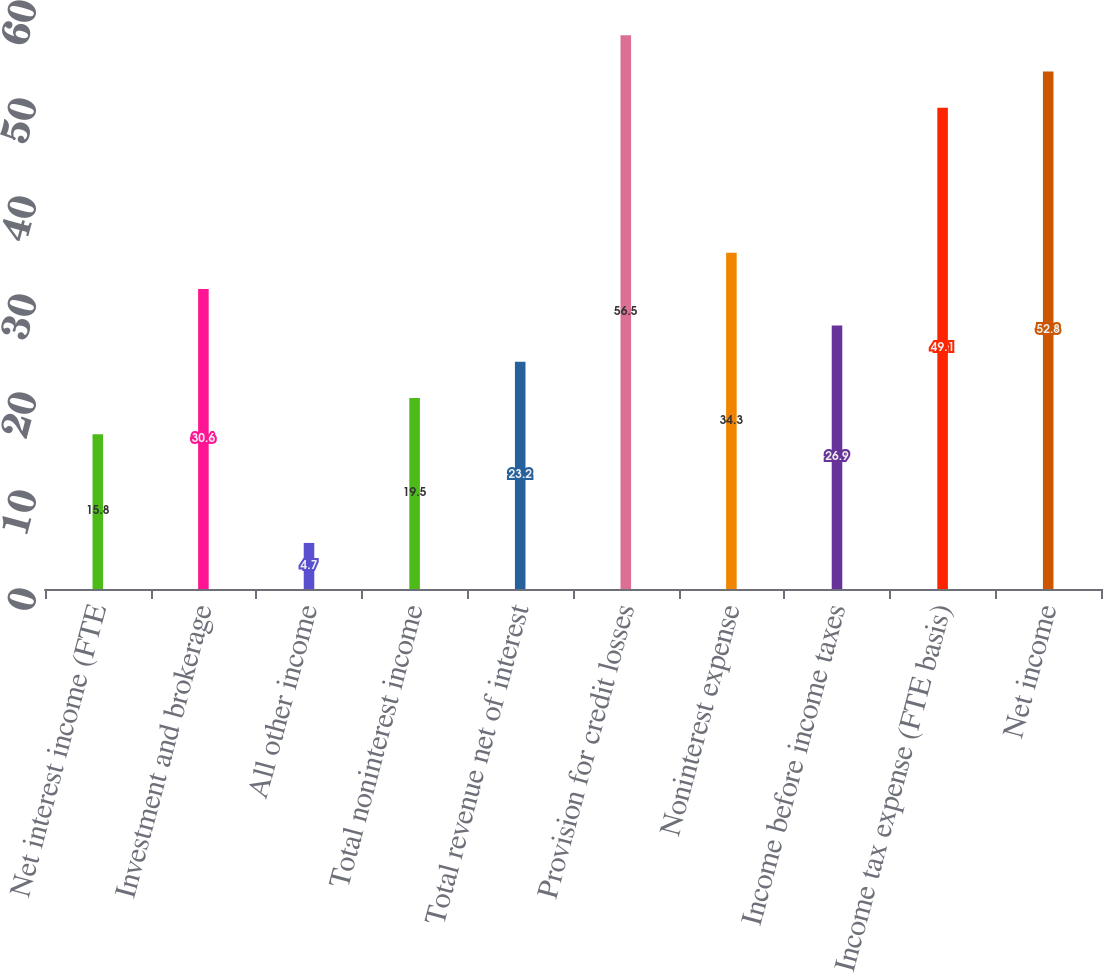Convert chart. <chart><loc_0><loc_0><loc_500><loc_500><bar_chart><fcel>Net interest income (FTE<fcel>Investment and brokerage<fcel>All other income<fcel>Total noninterest income<fcel>Total revenue net of interest<fcel>Provision for credit losses<fcel>Noninterest expense<fcel>Income before income taxes<fcel>Income tax expense (FTE basis)<fcel>Net income<nl><fcel>15.8<fcel>30.6<fcel>4.7<fcel>19.5<fcel>23.2<fcel>56.5<fcel>34.3<fcel>26.9<fcel>49.1<fcel>52.8<nl></chart> 